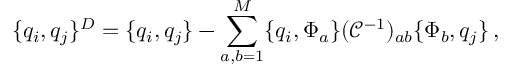Convert formula to latex. <formula><loc_0><loc_0><loc_500><loc_500>\{ q _ { i } , q _ { j } \} ^ { D } = \{ q _ { i } , q _ { j } \} - \sum _ { a , b = 1 } ^ { M } \{ q _ { i } , \Phi _ { a } \} ( \mathcal { C } ^ { - 1 } ) _ { a b } \{ \Phi _ { b } , q _ { j } \} \, ,</formula> 